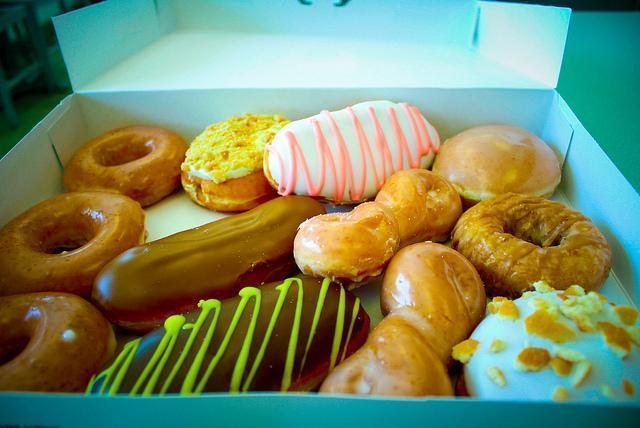What treat is in the box?
Choose the right answer and clarify with the format: 'Answer: answer
Rationale: rationale.'
Options: Gummy bears, donut, pizza, apple pie. Answer: donut.
Rationale: The box is filled with a dozen of sweet glazed donuts. 